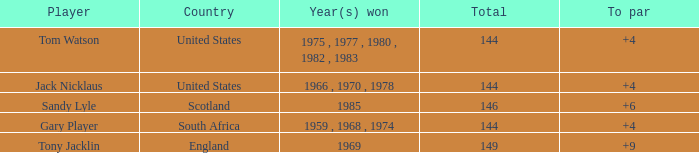What was England's total? 149.0. 